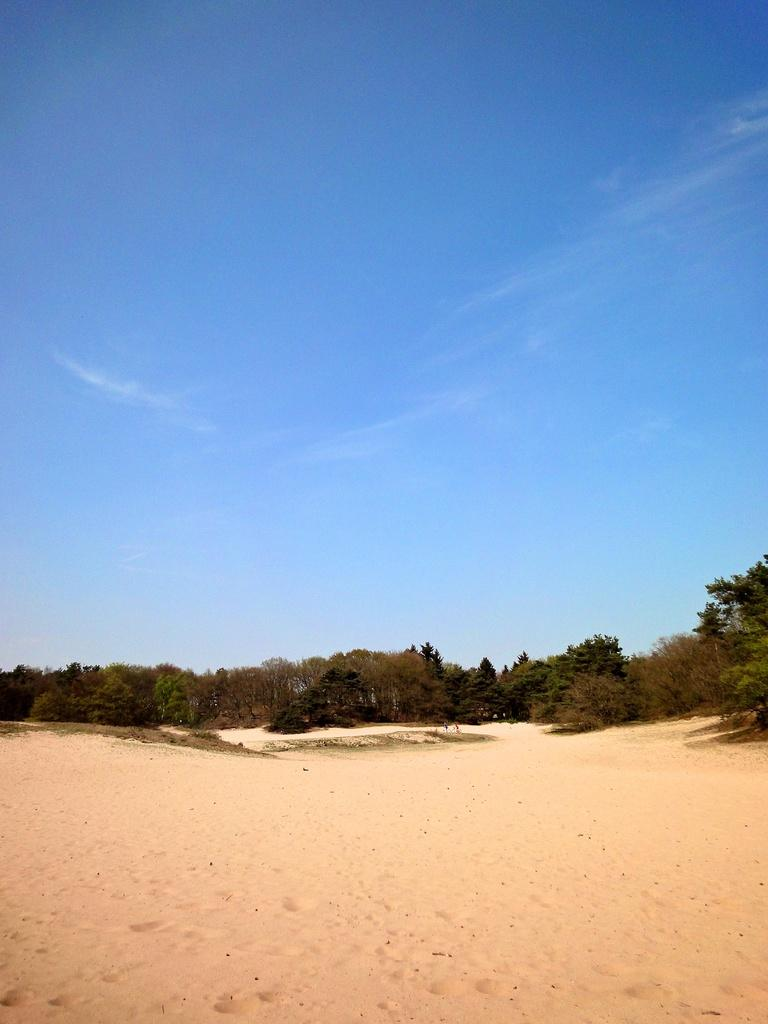What is at the bottom of the image? There is sand at the bottom of the image. What can be seen in the background of the image? There are trees in the background of the image. What is visible at the top of the image? The sky is visible at the top of the image. What type of vest is being worn by the tree in the image? There are no vests present in the image, as it features sand, trees, and the sky. What color is the hair of the sand in the image? There is no hair present in the image, as it features sand, trees, and the sky. 